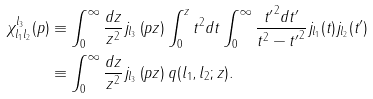Convert formula to latex. <formula><loc_0><loc_0><loc_500><loc_500>\chi _ { l _ { 1 } l _ { 2 } } ^ { l _ { 3 } } ( p ) & \equiv \int _ { 0 } ^ { \infty } \frac { d z } { z ^ { 2 } } j _ { l _ { 3 } } \left ( p z \right ) \int _ { 0 } ^ { z } t ^ { 2 } d t \int _ { 0 } ^ { \infty } \frac { { t ^ { \prime } } ^ { 2 } d t ^ { \prime } } { t ^ { 2 } - { t ^ { \prime } } ^ { 2 } } j _ { l _ { 1 } } ( t ) j _ { l _ { 2 } } ( t ^ { \prime } ) \\ & \equiv \int _ { 0 } ^ { \infty } \frac { d z } { z ^ { 2 } } j _ { l _ { 3 } } \left ( p z \right ) q ( l _ { 1 } , l _ { 2 } ; z ) .</formula> 